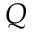Convert formula to latex. <formula><loc_0><loc_0><loc_500><loc_500>Q</formula> 